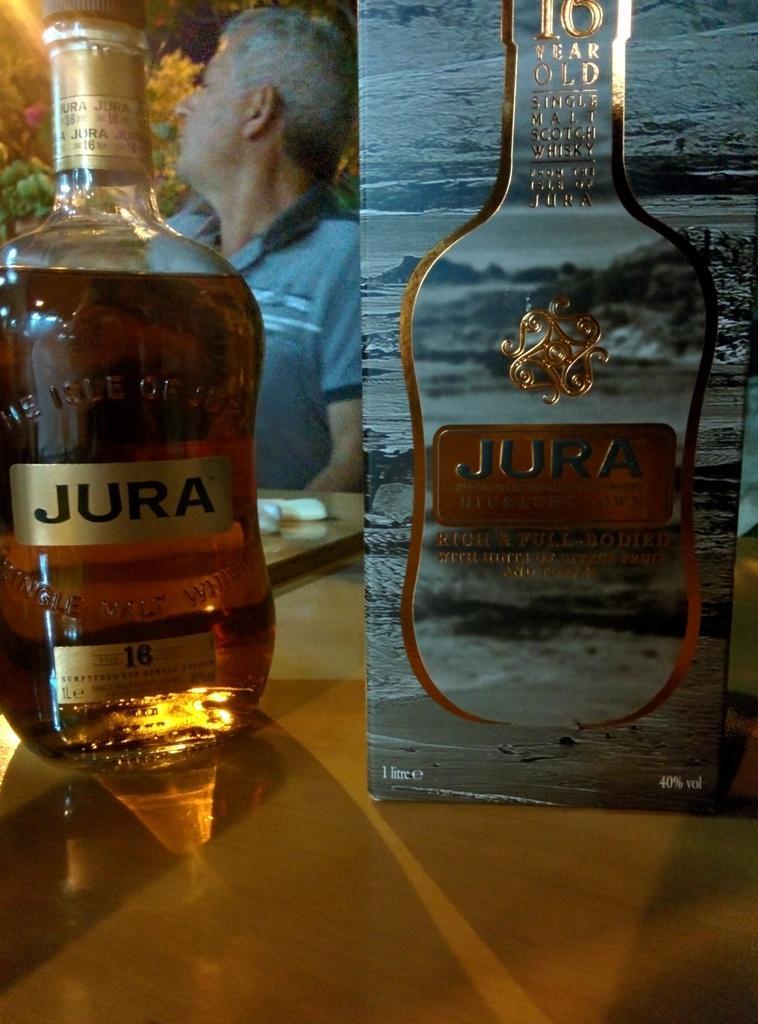Describe this image in one or two sentences. A wine bottle and its pack box are placed on a table. The name is labelled as "jura" on the bottle. A man is sitting at a table wearing a T shirt. There are some trees and light in the background. 